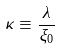<formula> <loc_0><loc_0><loc_500><loc_500>\kappa \equiv \frac { \lambda } { \xi _ { 0 } }</formula> 